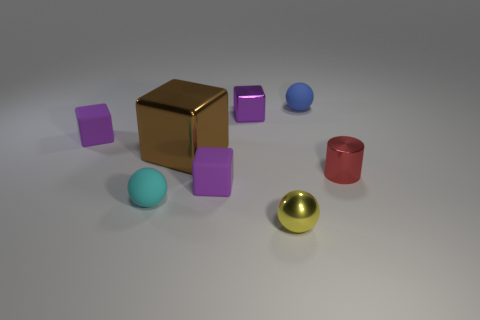Subtract all cyan balls. How many purple cubes are left? 3 Add 1 small red cylinders. How many objects exist? 9 Subtract all spheres. How many objects are left? 5 Subtract 0 red balls. How many objects are left? 8 Subtract all tiny matte blocks. Subtract all big brown metal things. How many objects are left? 5 Add 5 small cyan rubber balls. How many small cyan rubber balls are left? 6 Add 2 small gray metallic objects. How many small gray metallic objects exist? 2 